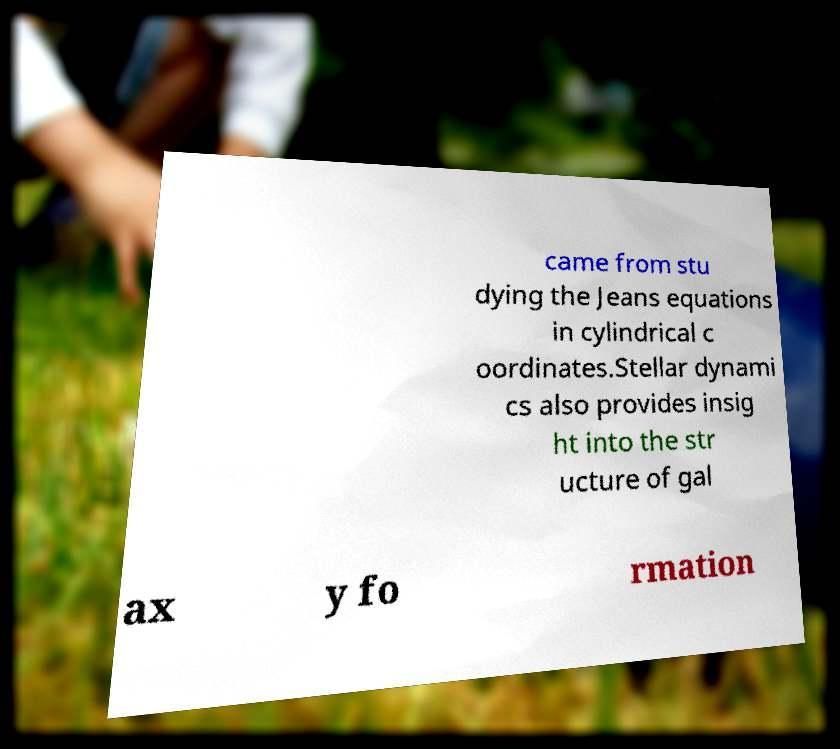There's text embedded in this image that I need extracted. Can you transcribe it verbatim? came from stu dying the Jeans equations in cylindrical c oordinates.Stellar dynami cs also provides insig ht into the str ucture of gal ax y fo rmation 